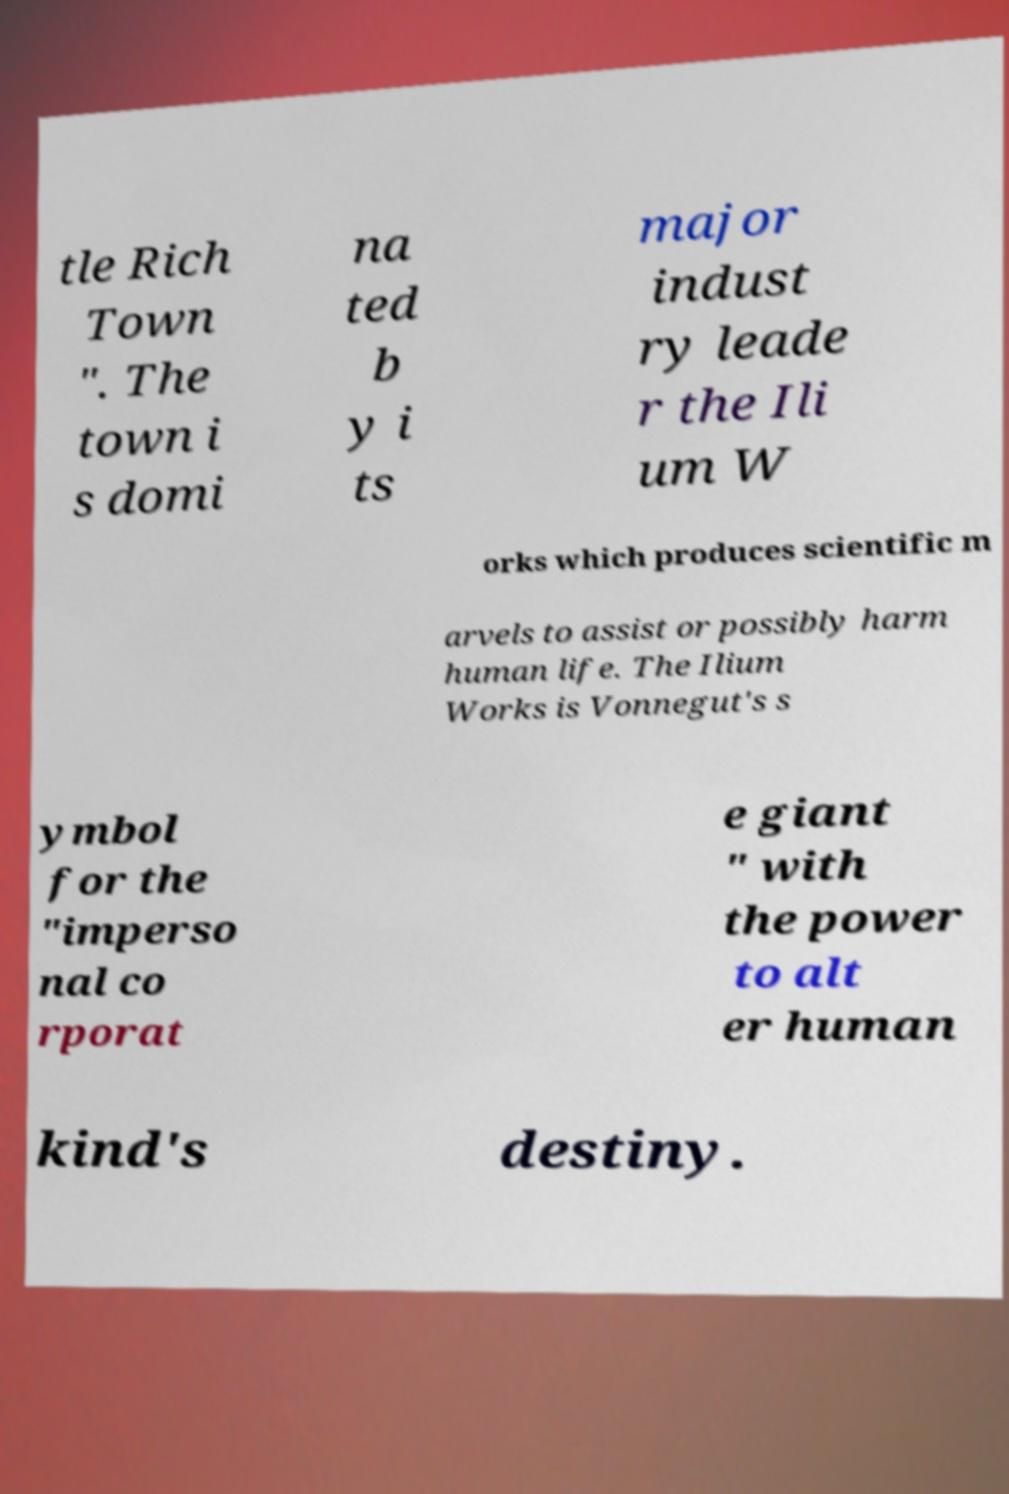Can you read and provide the text displayed in the image?This photo seems to have some interesting text. Can you extract and type it out for me? tle Rich Town ". The town i s domi na ted b y i ts major indust ry leade r the Ili um W orks which produces scientific m arvels to assist or possibly harm human life. The Ilium Works is Vonnegut's s ymbol for the "imperso nal co rporat e giant " with the power to alt er human kind's destiny. 